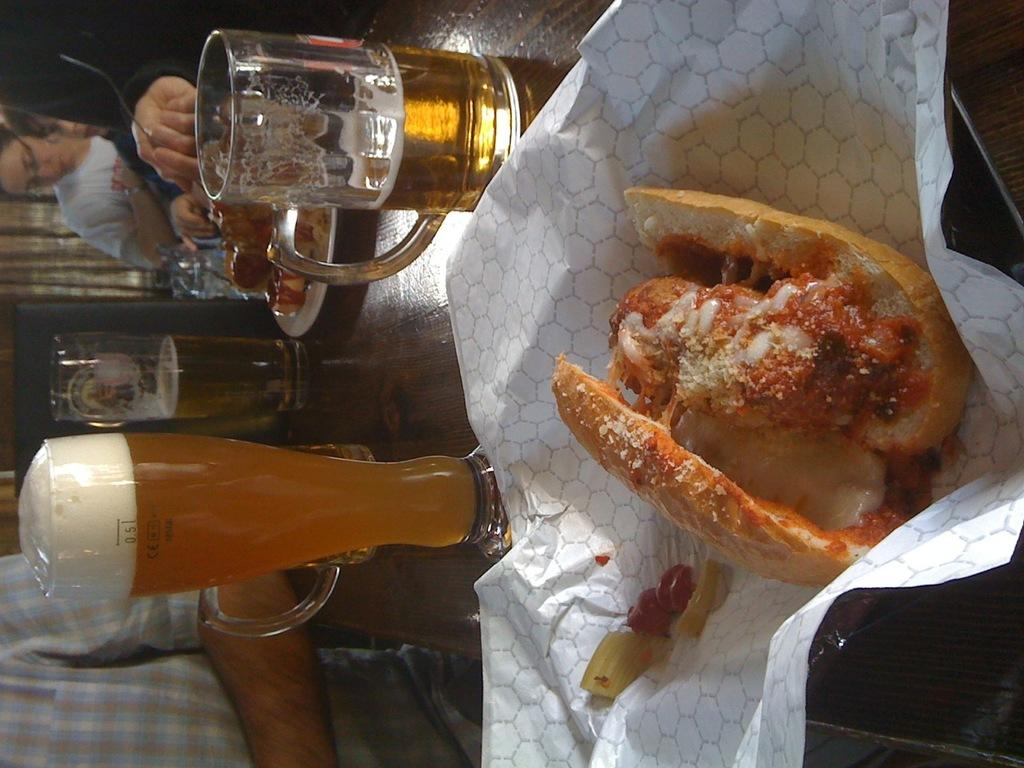What type of glasses can be seen in the image? There are wine glasses in the image. What else is present on the table besides the wine glasses? There is food on the table in the image. Can you describe the people in the image? There are people present in the image. What is the chance of winning the lottery in the image? There is no mention of a lottery or any chance of winning in the image. 